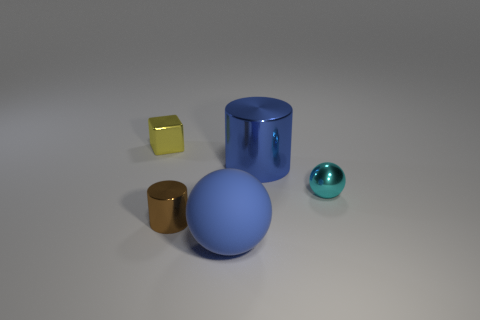There is a tiny shiny thing on the right side of the blue matte sphere; what color is it? cyan 